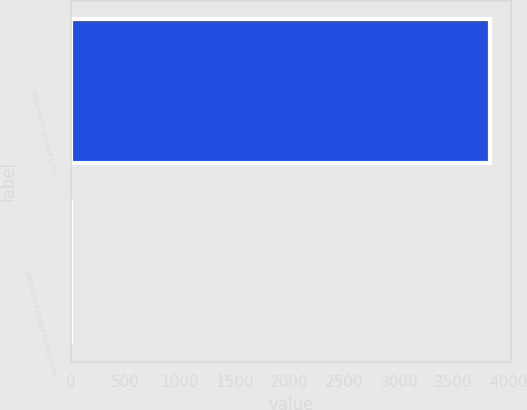Convert chart to OTSL. <chart><loc_0><loc_0><loc_500><loc_500><bar_chart><fcel>Repayment amount (US)<fcel>Weighted average interest rate<nl><fcel>3834<fcel>6.9<nl></chart> 